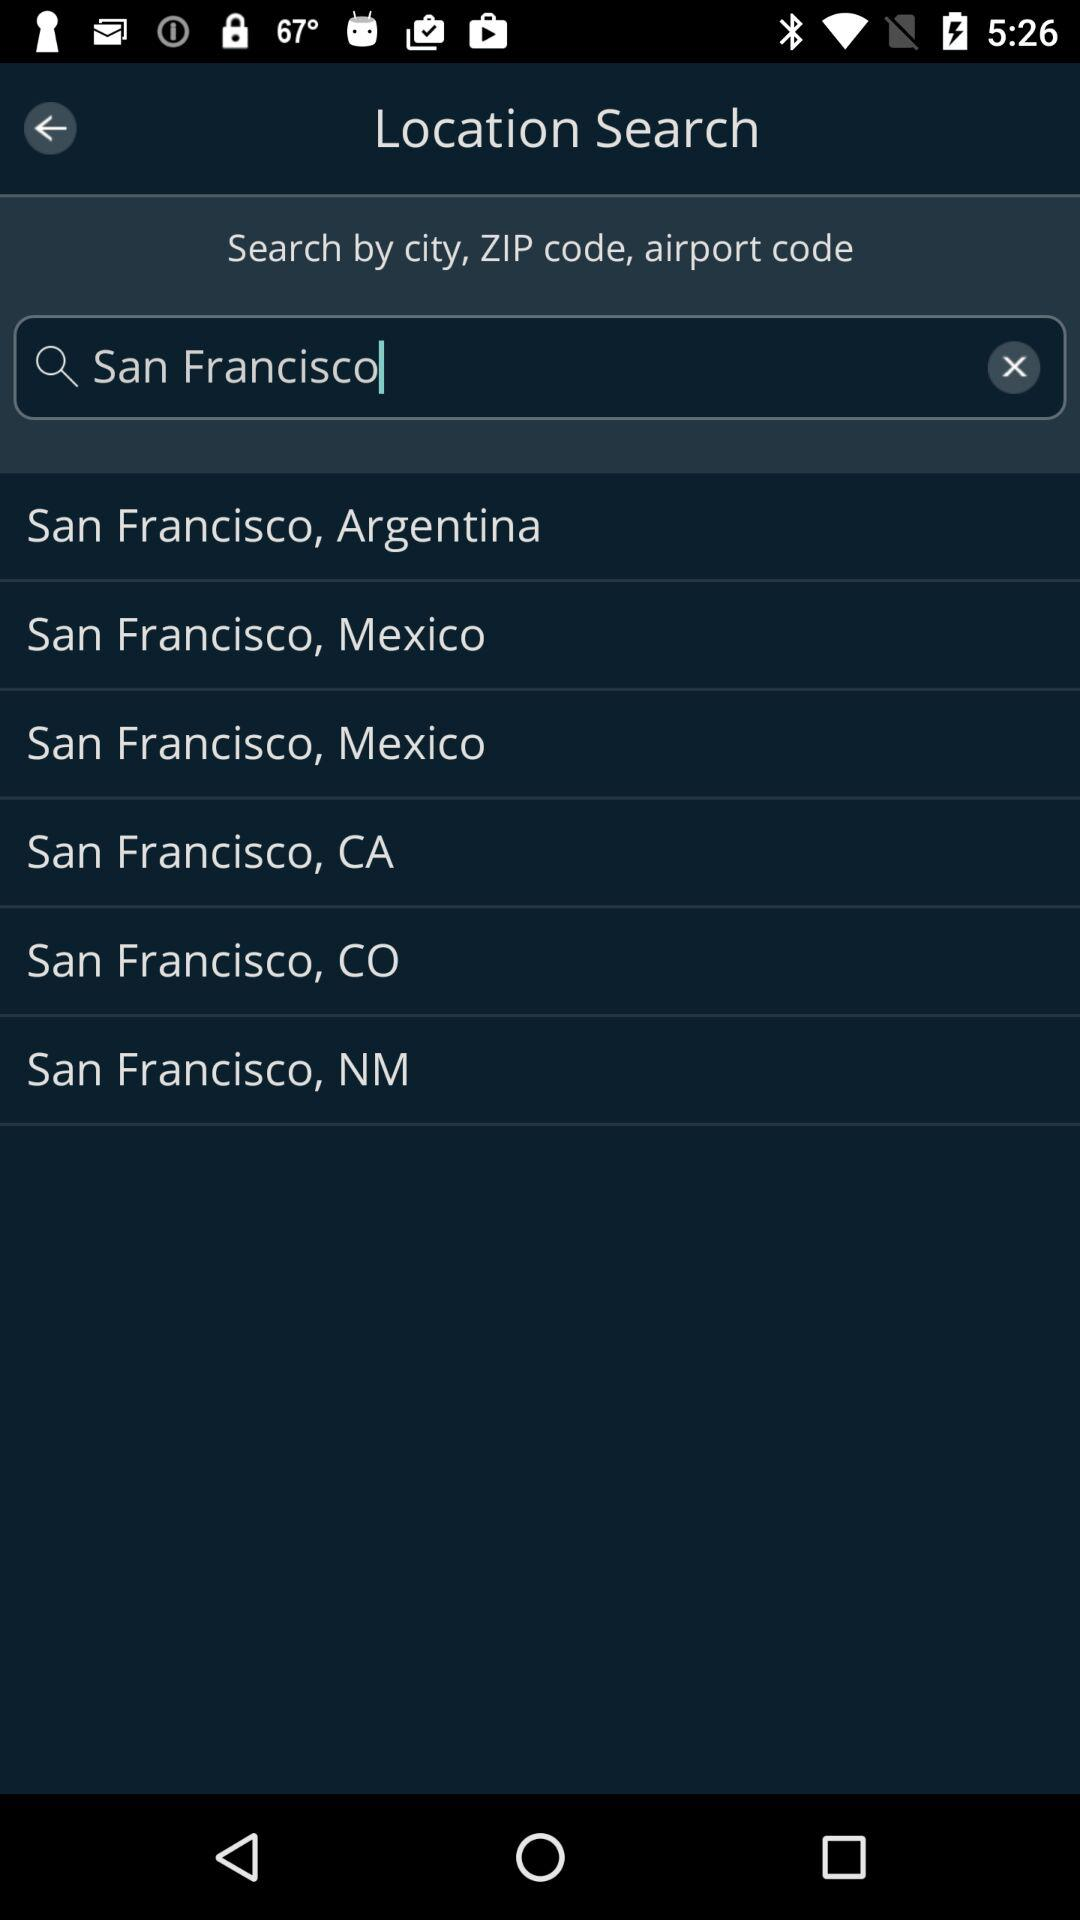What is the search city? The search city is San Francisco. 